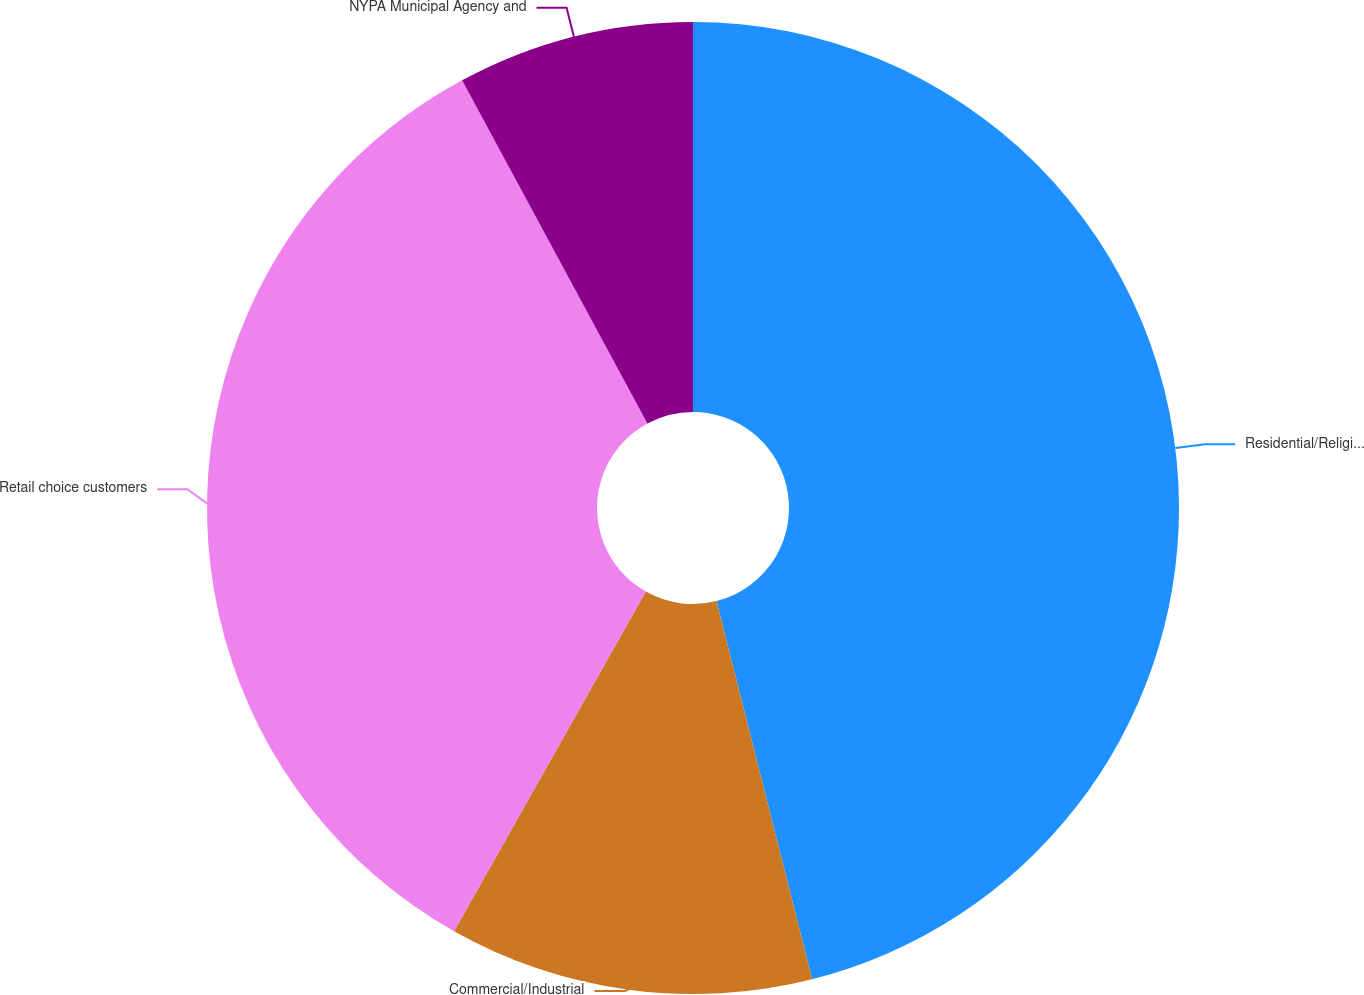<chart> <loc_0><loc_0><loc_500><loc_500><pie_chart><fcel>Residential/Religious (b)<fcel>Commercial/Industrial<fcel>Retail choice customers<fcel>NYPA Municipal Agency and<nl><fcel>46.06%<fcel>12.12%<fcel>33.94%<fcel>7.88%<nl></chart> 